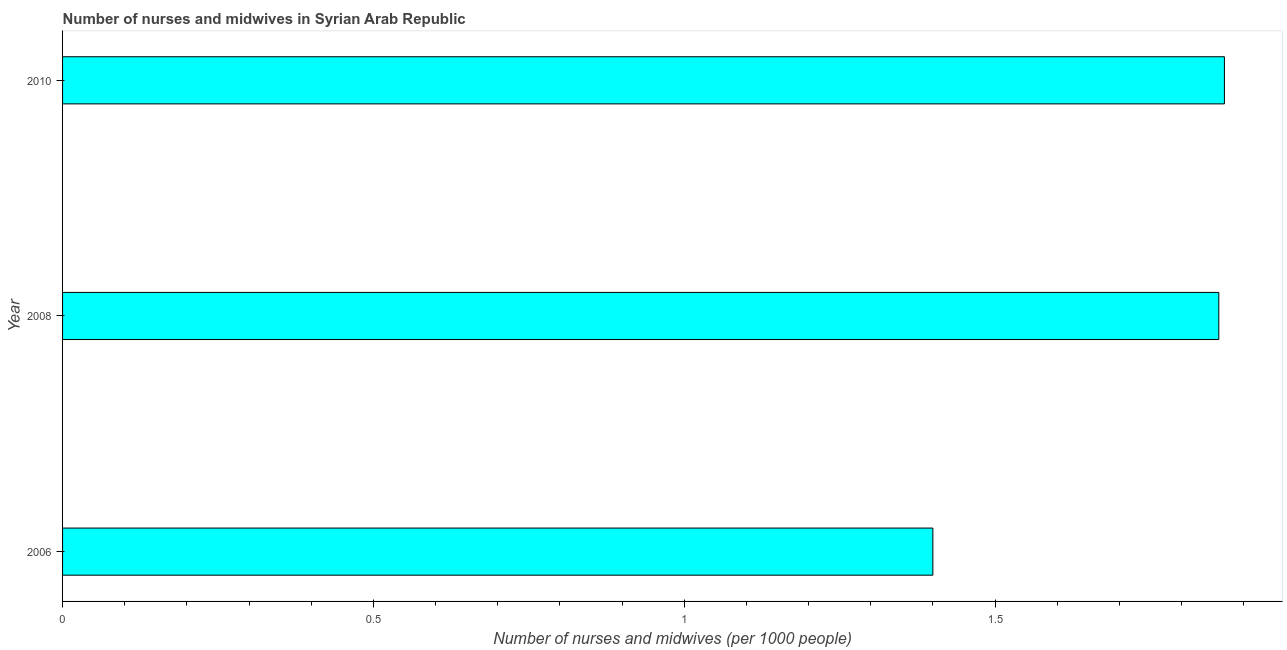Does the graph contain grids?
Your response must be concise. No. What is the title of the graph?
Your response must be concise. Number of nurses and midwives in Syrian Arab Republic. What is the label or title of the X-axis?
Make the answer very short. Number of nurses and midwives (per 1000 people). What is the number of nurses and midwives in 2008?
Keep it short and to the point. 1.86. Across all years, what is the maximum number of nurses and midwives?
Give a very brief answer. 1.87. Across all years, what is the minimum number of nurses and midwives?
Offer a very short reply. 1.4. In which year was the number of nurses and midwives minimum?
Offer a terse response. 2006. What is the sum of the number of nurses and midwives?
Ensure brevity in your answer.  5.13. What is the difference between the number of nurses and midwives in 2006 and 2010?
Provide a short and direct response. -0.47. What is the average number of nurses and midwives per year?
Offer a very short reply. 1.71. What is the median number of nurses and midwives?
Your answer should be compact. 1.86. In how many years, is the number of nurses and midwives greater than 0.5 ?
Make the answer very short. 3. Do a majority of the years between 2008 and 2006 (inclusive) have number of nurses and midwives greater than 1.2 ?
Provide a succinct answer. No. What is the ratio of the number of nurses and midwives in 2008 to that in 2010?
Keep it short and to the point. 0.99. Is the difference between the number of nurses and midwives in 2006 and 2008 greater than the difference between any two years?
Your answer should be very brief. No. What is the difference between the highest and the second highest number of nurses and midwives?
Ensure brevity in your answer.  0.01. Is the sum of the number of nurses and midwives in 2006 and 2010 greater than the maximum number of nurses and midwives across all years?
Provide a succinct answer. Yes. What is the difference between the highest and the lowest number of nurses and midwives?
Make the answer very short. 0.47. Are all the bars in the graph horizontal?
Ensure brevity in your answer.  Yes. How many years are there in the graph?
Your answer should be compact. 3. What is the difference between two consecutive major ticks on the X-axis?
Keep it short and to the point. 0.5. Are the values on the major ticks of X-axis written in scientific E-notation?
Ensure brevity in your answer.  No. What is the Number of nurses and midwives (per 1000 people) in 2008?
Provide a short and direct response. 1.86. What is the Number of nurses and midwives (per 1000 people) of 2010?
Provide a succinct answer. 1.87. What is the difference between the Number of nurses and midwives (per 1000 people) in 2006 and 2008?
Keep it short and to the point. -0.46. What is the difference between the Number of nurses and midwives (per 1000 people) in 2006 and 2010?
Ensure brevity in your answer.  -0.47. What is the difference between the Number of nurses and midwives (per 1000 people) in 2008 and 2010?
Your answer should be very brief. -0.01. What is the ratio of the Number of nurses and midwives (per 1000 people) in 2006 to that in 2008?
Offer a very short reply. 0.75. What is the ratio of the Number of nurses and midwives (per 1000 people) in 2006 to that in 2010?
Give a very brief answer. 0.75. 